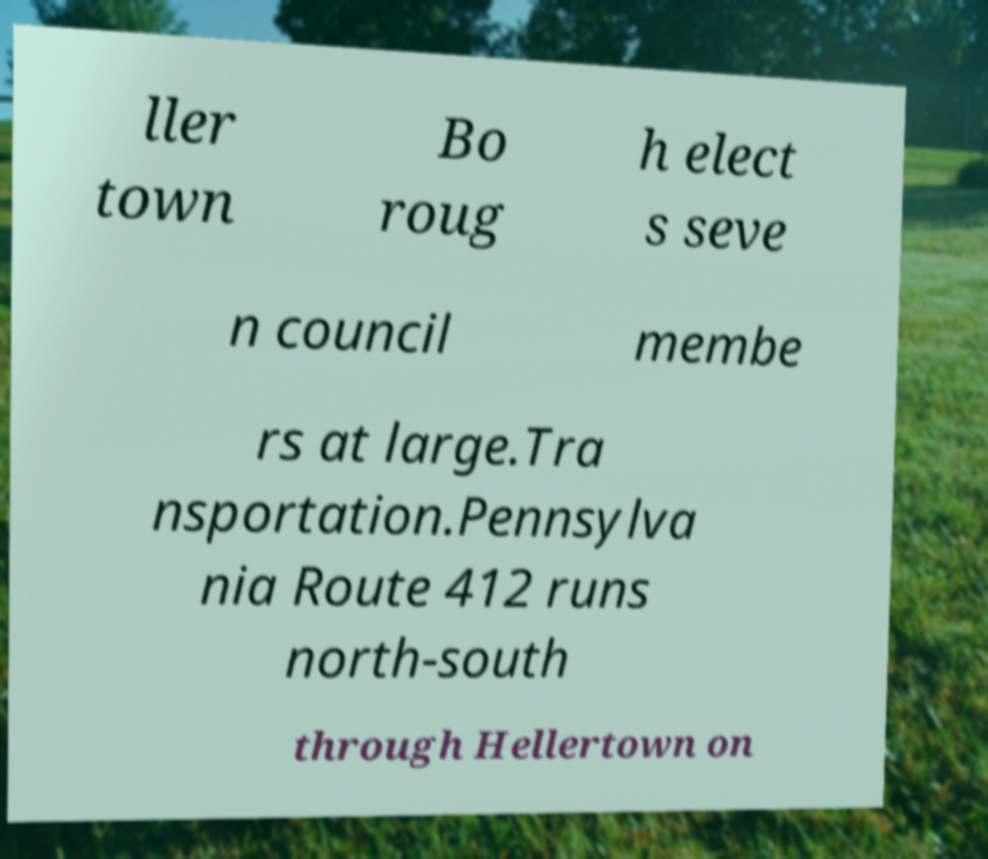I need the written content from this picture converted into text. Can you do that? ller town Bo roug h elect s seve n council membe rs at large.Tra nsportation.Pennsylva nia Route 412 runs north-south through Hellertown on 